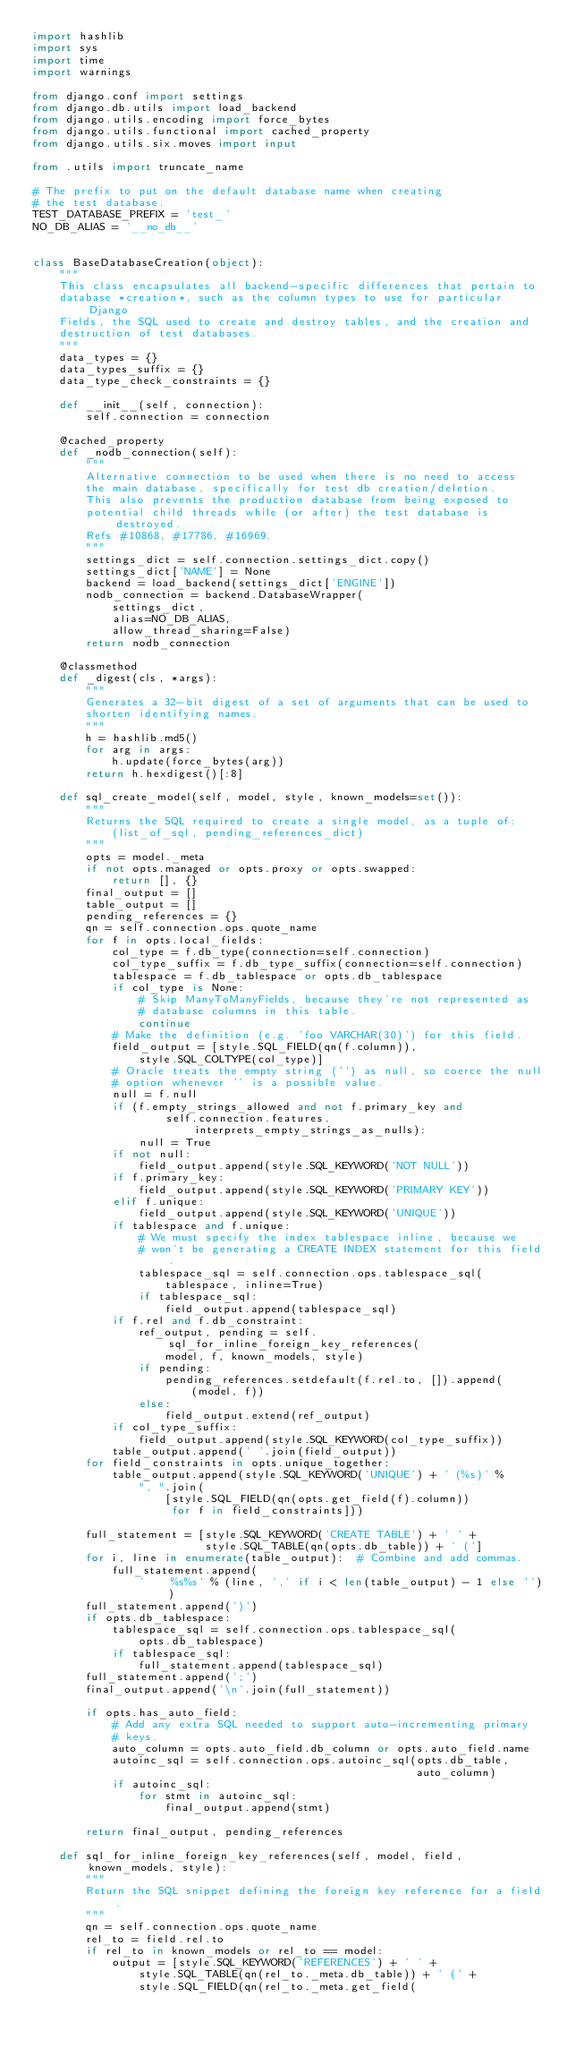Convert code to text. <code><loc_0><loc_0><loc_500><loc_500><_Python_>import hashlib
import sys
import time
import warnings

from django.conf import settings
from django.db.utils import load_backend
from django.utils.encoding import force_bytes
from django.utils.functional import cached_property
from django.utils.six.moves import input

from .utils import truncate_name

# The prefix to put on the default database name when creating
# the test database.
TEST_DATABASE_PREFIX = 'test_'
NO_DB_ALIAS = '__no_db__'


class BaseDatabaseCreation(object):
    """
    This class encapsulates all backend-specific differences that pertain to
    database *creation*, such as the column types to use for particular Django
    Fields, the SQL used to create and destroy tables, and the creation and
    destruction of test databases.
    """
    data_types = {}
    data_types_suffix = {}
    data_type_check_constraints = {}

    def __init__(self, connection):
        self.connection = connection

    @cached_property
    def _nodb_connection(self):
        """
        Alternative connection to be used when there is no need to access
        the main database, specifically for test db creation/deletion.
        This also prevents the production database from being exposed to
        potential child threads while (or after) the test database is destroyed.
        Refs #10868, #17786, #16969.
        """
        settings_dict = self.connection.settings_dict.copy()
        settings_dict['NAME'] = None
        backend = load_backend(settings_dict['ENGINE'])
        nodb_connection = backend.DatabaseWrapper(
            settings_dict,
            alias=NO_DB_ALIAS,
            allow_thread_sharing=False)
        return nodb_connection

    @classmethod
    def _digest(cls, *args):
        """
        Generates a 32-bit digest of a set of arguments that can be used to
        shorten identifying names.
        """
        h = hashlib.md5()
        for arg in args:
            h.update(force_bytes(arg))
        return h.hexdigest()[:8]

    def sql_create_model(self, model, style, known_models=set()):
        """
        Returns the SQL required to create a single model, as a tuple of:
            (list_of_sql, pending_references_dict)
        """
        opts = model._meta
        if not opts.managed or opts.proxy or opts.swapped:
            return [], {}
        final_output = []
        table_output = []
        pending_references = {}
        qn = self.connection.ops.quote_name
        for f in opts.local_fields:
            col_type = f.db_type(connection=self.connection)
            col_type_suffix = f.db_type_suffix(connection=self.connection)
            tablespace = f.db_tablespace or opts.db_tablespace
            if col_type is None:
                # Skip ManyToManyFields, because they're not represented as
                # database columns in this table.
                continue
            # Make the definition (e.g. 'foo VARCHAR(30)') for this field.
            field_output = [style.SQL_FIELD(qn(f.column)),
                style.SQL_COLTYPE(col_type)]
            # Oracle treats the empty string ('') as null, so coerce the null
            # option whenever '' is a possible value.
            null = f.null
            if (f.empty_strings_allowed and not f.primary_key and
                    self.connection.features.interprets_empty_strings_as_nulls):
                null = True
            if not null:
                field_output.append(style.SQL_KEYWORD('NOT NULL'))
            if f.primary_key:
                field_output.append(style.SQL_KEYWORD('PRIMARY KEY'))
            elif f.unique:
                field_output.append(style.SQL_KEYWORD('UNIQUE'))
            if tablespace and f.unique:
                # We must specify the index tablespace inline, because we
                # won't be generating a CREATE INDEX statement for this field.
                tablespace_sql = self.connection.ops.tablespace_sql(
                    tablespace, inline=True)
                if tablespace_sql:
                    field_output.append(tablespace_sql)
            if f.rel and f.db_constraint:
                ref_output, pending = self.sql_for_inline_foreign_key_references(
                    model, f, known_models, style)
                if pending:
                    pending_references.setdefault(f.rel.to, []).append(
                        (model, f))
                else:
                    field_output.extend(ref_output)
            if col_type_suffix:
                field_output.append(style.SQL_KEYWORD(col_type_suffix))
            table_output.append(' '.join(field_output))
        for field_constraints in opts.unique_together:
            table_output.append(style.SQL_KEYWORD('UNIQUE') + ' (%s)' %
                ", ".join(
                    [style.SQL_FIELD(qn(opts.get_field(f).column))
                     for f in field_constraints]))

        full_statement = [style.SQL_KEYWORD('CREATE TABLE') + ' ' +
                          style.SQL_TABLE(qn(opts.db_table)) + ' (']
        for i, line in enumerate(table_output):  # Combine and add commas.
            full_statement.append(
                '    %s%s' % (line, ',' if i < len(table_output) - 1 else ''))
        full_statement.append(')')
        if opts.db_tablespace:
            tablespace_sql = self.connection.ops.tablespace_sql(
                opts.db_tablespace)
            if tablespace_sql:
                full_statement.append(tablespace_sql)
        full_statement.append(';')
        final_output.append('\n'.join(full_statement))

        if opts.has_auto_field:
            # Add any extra SQL needed to support auto-incrementing primary
            # keys.
            auto_column = opts.auto_field.db_column or opts.auto_field.name
            autoinc_sql = self.connection.ops.autoinc_sql(opts.db_table,
                                                          auto_column)
            if autoinc_sql:
                for stmt in autoinc_sql:
                    final_output.append(stmt)

        return final_output, pending_references

    def sql_for_inline_foreign_key_references(self, model, field, known_models, style):
        """
        Return the SQL snippet defining the foreign key reference for a field.
        """
        qn = self.connection.ops.quote_name
        rel_to = field.rel.to
        if rel_to in known_models or rel_to == model:
            output = [style.SQL_KEYWORD('REFERENCES') + ' ' +
                style.SQL_TABLE(qn(rel_to._meta.db_table)) + ' (' +
                style.SQL_FIELD(qn(rel_to._meta.get_field(</code> 